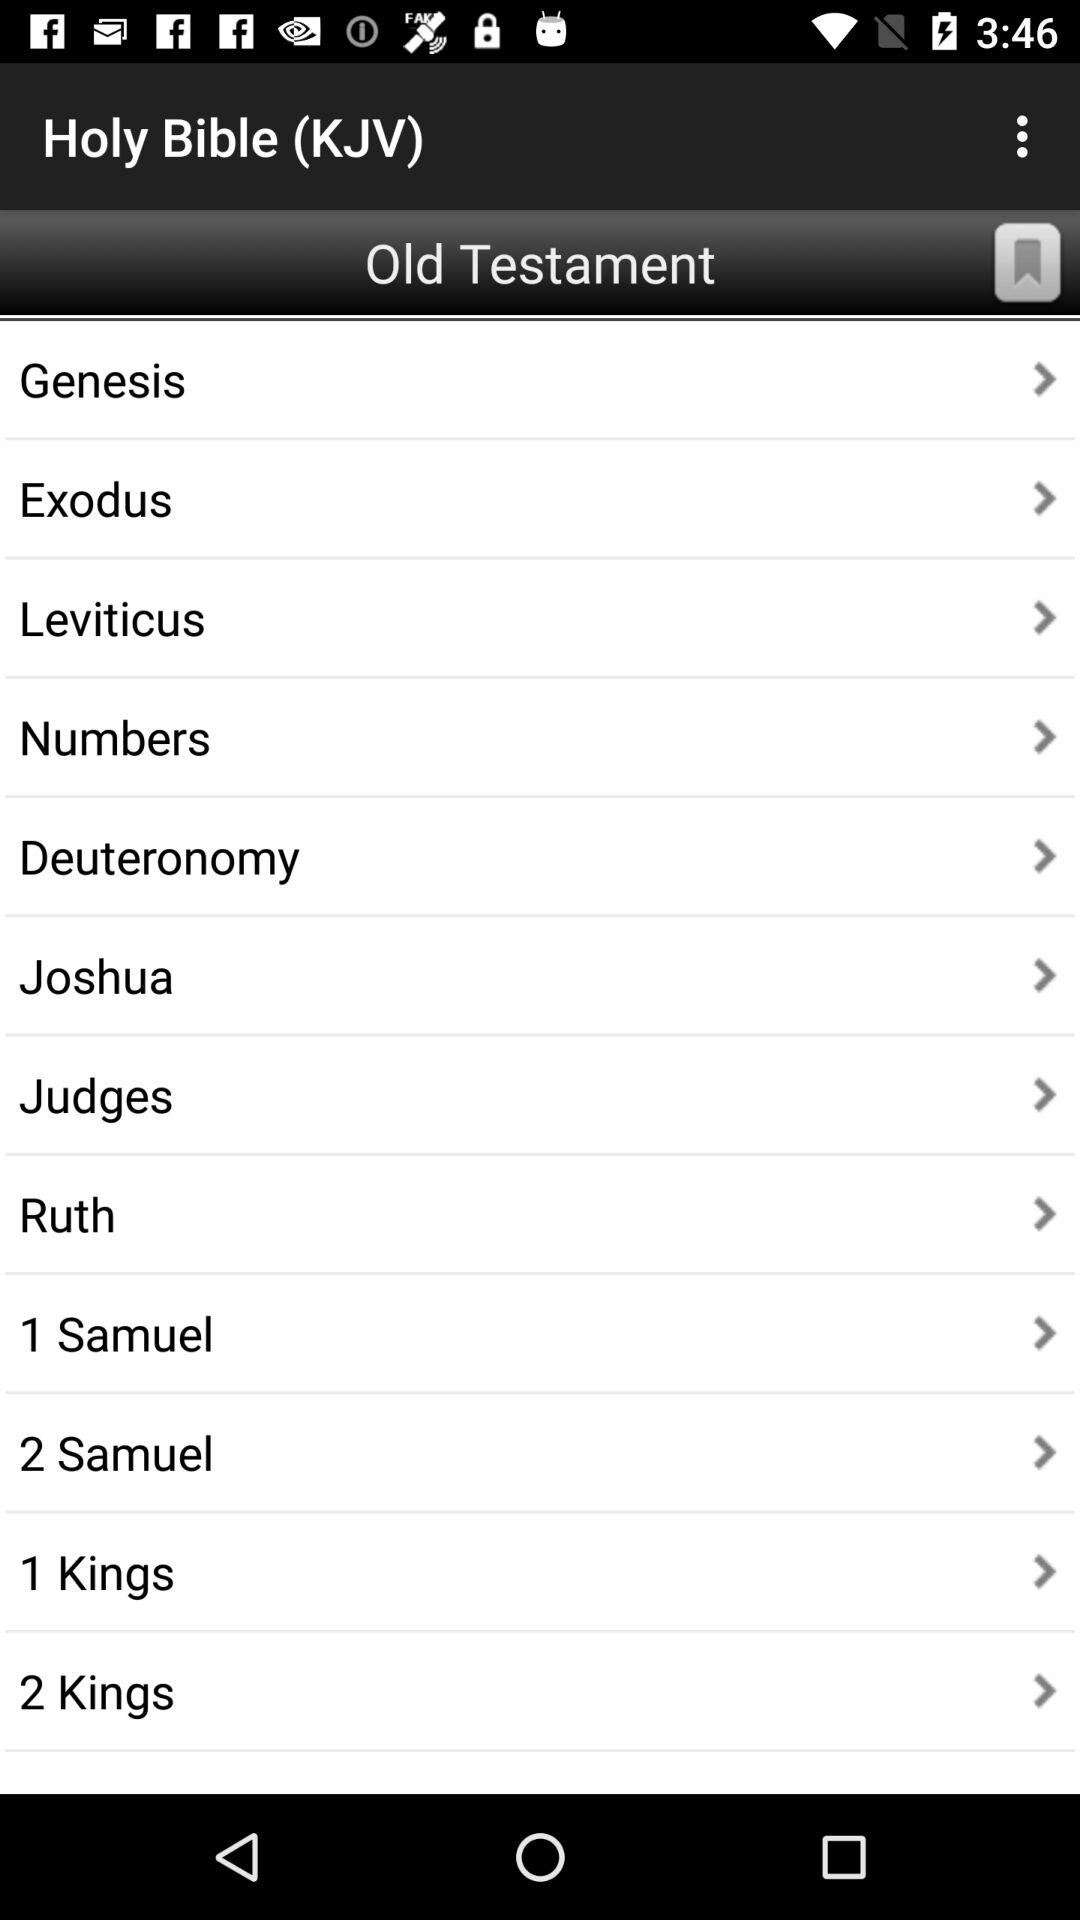What is the name of the application? The name of the application is "Holy Bible (KJV)". 